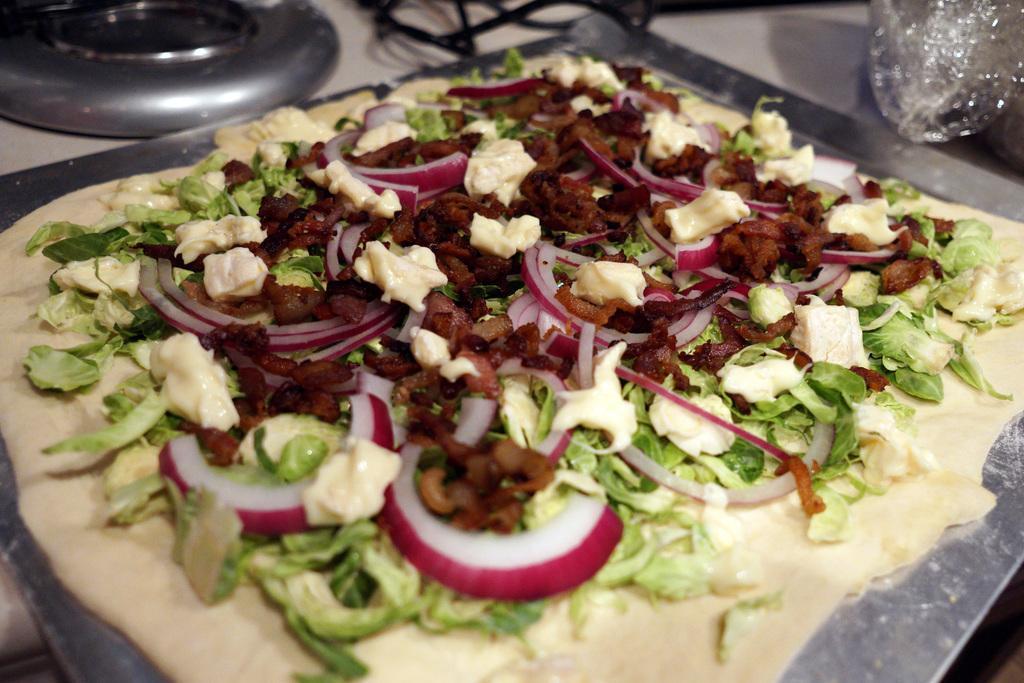Can you describe this image briefly? In the picture I can see the food item on the stainless steel plate. It is looking like the gas burner on the top left side of the picture. 